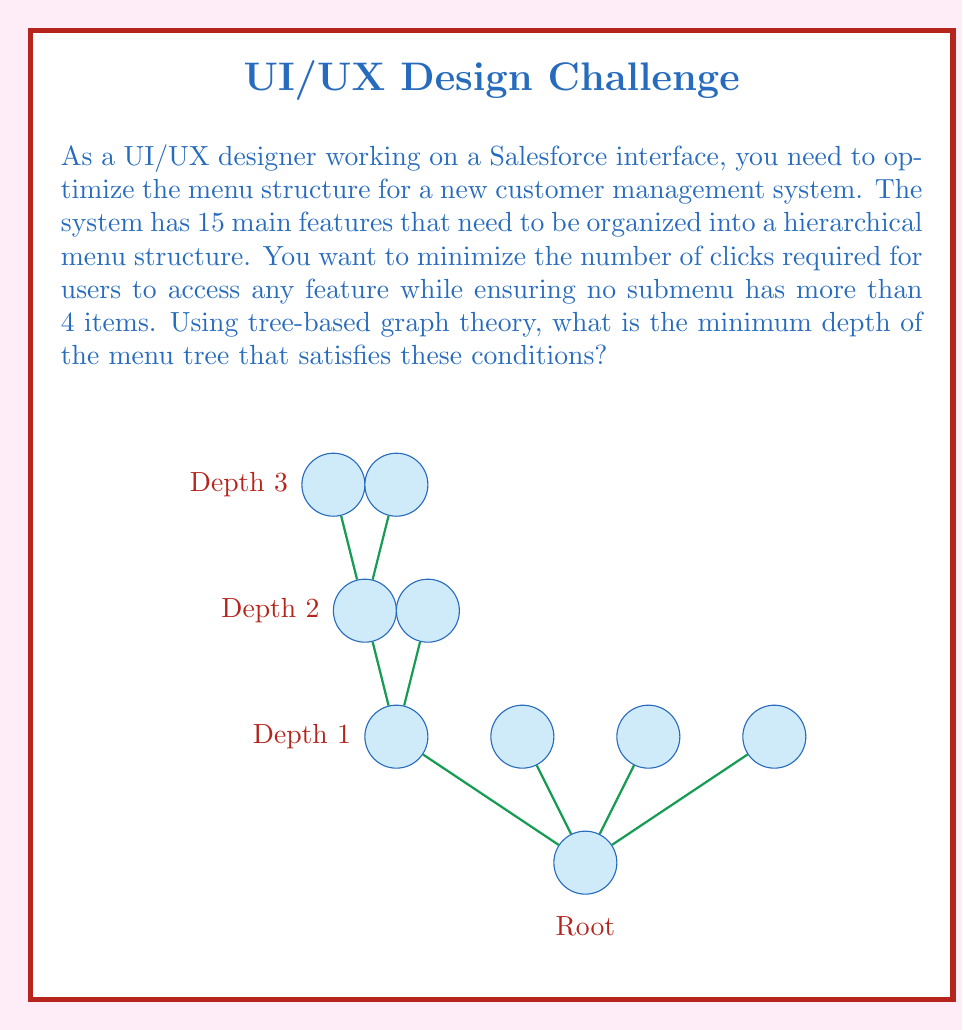What is the answer to this math problem? To solve this problem, we need to use the concept of tree depth and branching factor in graph theory. Let's approach this step-by-step:

1) We have 15 features that need to be accessible, and each submenu can have at most 4 items.

2) In tree terminology, this means:
   - We need at least 15 leaf nodes (one for each feature)
   - Each internal node (including the root) can have at most 4 children

3) Let's consider the possible depths:

   Depth 1: Only the root, maximum 4 items. Not enough.

   Depth 2: Root with 4 children, each with 4 leaves.
   Total leaves = $4 * 4 = 16$
   This is just enough to accommodate our 15 features.

4) We can represent this mathematically:

   Let $n$ be the number of features, $b$ be the maximum branching factor (items per submenu), and $d$ be the depth.

   The maximum number of leaves in a tree of depth $d$ is given by:

   $$ n \leq b^d $$

5) In our case:
   $$ 15 \leq 4^d $$

6) Taking $\log_4$ of both sides:
   $$ \log_4(15) \leq d $$

7) $\log_4(15) \approx 1.9544$

8) Since $d$ must be an integer, the minimum depth that satisfies this inequality is 2.

Therefore, a tree with depth 2 (root + two levels) is sufficient and optimal for this menu structure.
Answer: 2 